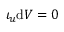<formula> <loc_0><loc_0><loc_500><loc_500>\iota _ { u } d V = 0</formula> 